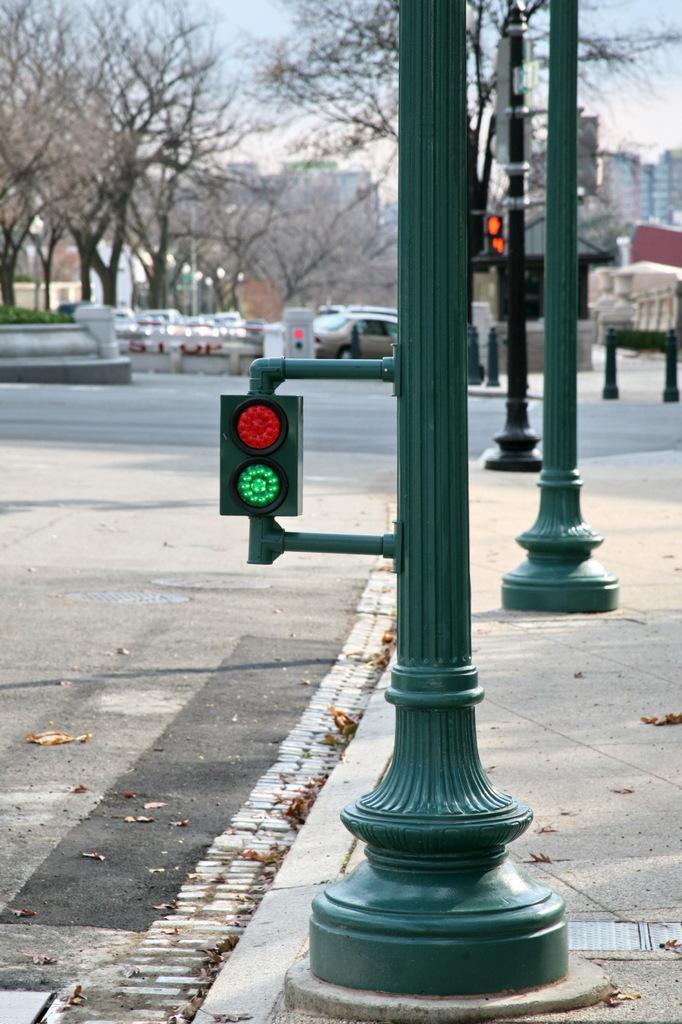Could you give a brief overview of what you see in this image? On the right side of the image we can see few poles and lights, in the background we can find few trees, vehicles and buildings. 